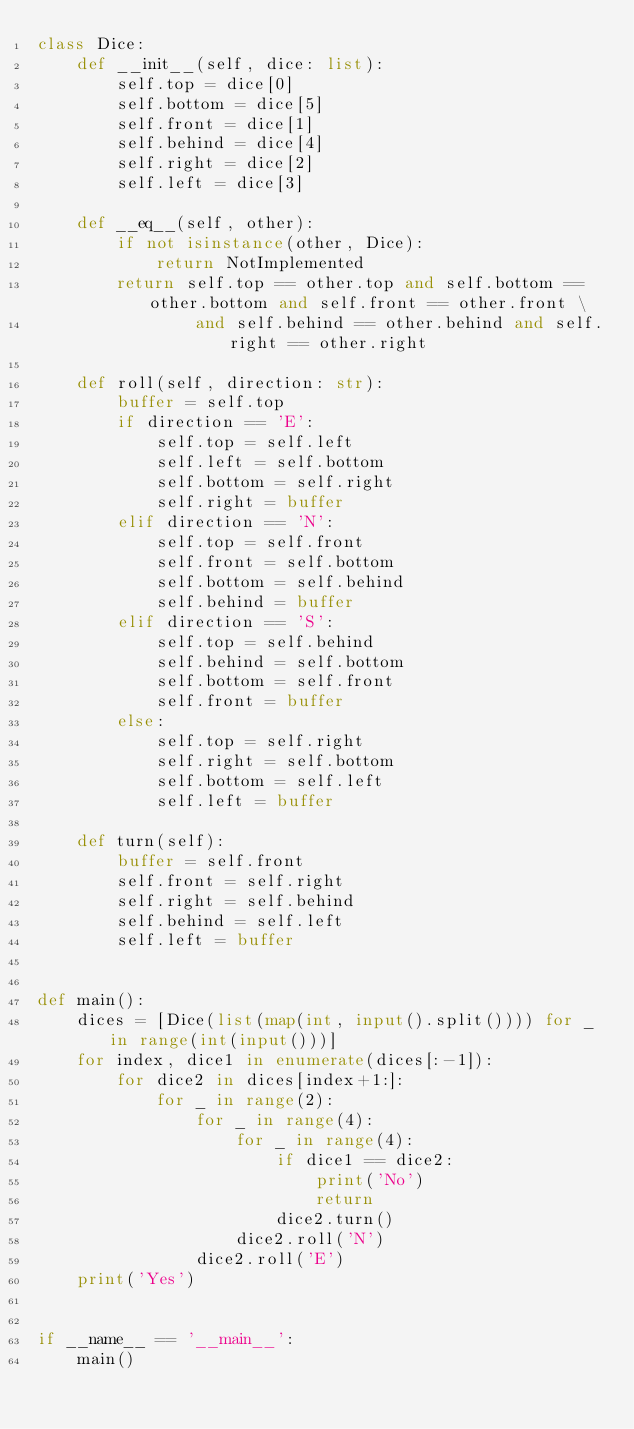<code> <loc_0><loc_0><loc_500><loc_500><_Python_>class Dice:
    def __init__(self, dice: list):
        self.top = dice[0]
        self.bottom = dice[5]
        self.front = dice[1]
        self.behind = dice[4]
        self.right = dice[2]
        self.left = dice[3]

    def __eq__(self, other):
        if not isinstance(other, Dice):
            return NotImplemented
        return self.top == other.top and self.bottom == other.bottom and self.front == other.front \
                and self.behind == other.behind and self.right == other.right

    def roll(self, direction: str):
        buffer = self.top
        if direction == 'E':
            self.top = self.left
            self.left = self.bottom
            self.bottom = self.right
            self.right = buffer
        elif direction == 'N':
            self.top = self.front
            self.front = self.bottom
            self.bottom = self.behind
            self.behind = buffer
        elif direction == 'S':
            self.top = self.behind
            self.behind = self.bottom
            self.bottom = self.front
            self.front = buffer
        else:
            self.top = self.right
            self.right = self.bottom
            self.bottom = self.left
            self.left = buffer

    def turn(self):
        buffer = self.front
        self.front = self.right
        self.right = self.behind
        self.behind = self.left
        self.left = buffer


def main():
    dices = [Dice(list(map(int, input().split()))) for _ in range(int(input()))]
    for index, dice1 in enumerate(dices[:-1]):
        for dice2 in dices[index+1:]:
            for _ in range(2):
                for _ in range(4):
                    for _ in range(4):
                        if dice1 == dice2:
                            print('No')
                            return
                        dice2.turn()
                    dice2.roll('N')
                dice2.roll('E')
    print('Yes')


if __name__ == '__main__':
    main()

</code> 